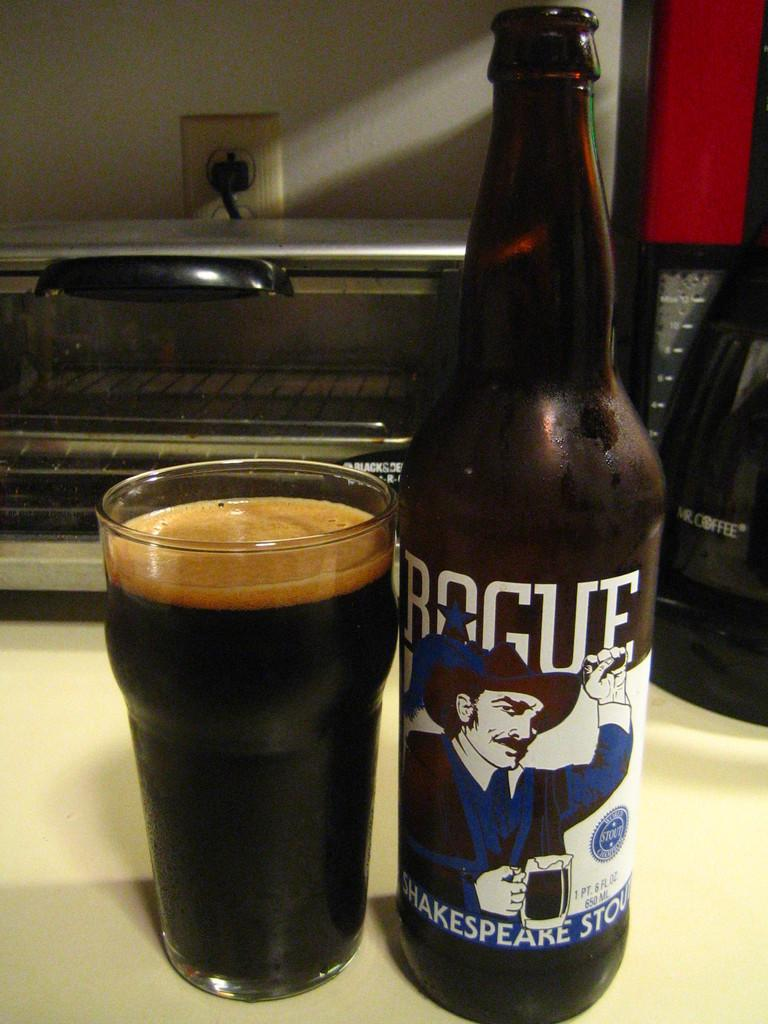<image>
Offer a succinct explanation of the picture presented. Rogue Shakespeare Stout beer bottle and glass sitting in front of toaster oven 